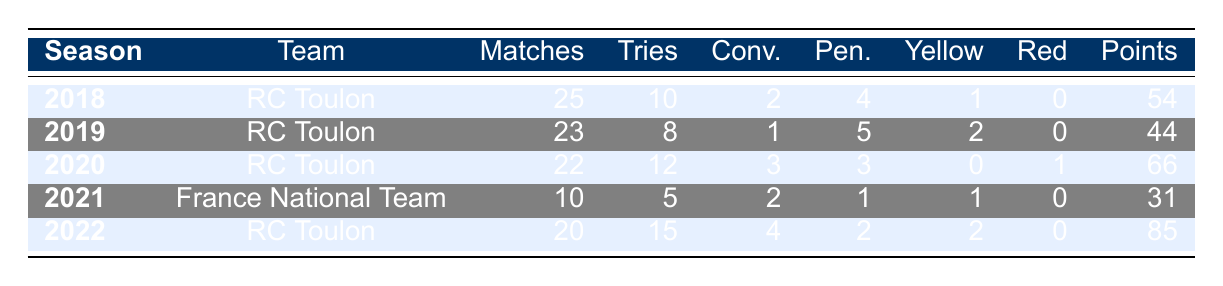What was Léo Laurent's highest total points scored in a season? In the table, the total points for each season are as follows: 54 (2018), 44 (2019), 66 (2020), 31 (2021), and 85 (2022). The highest value is 85, which corresponds to the 2022 season.
Answer: 85 How many matches did Léo Laurent play in total over all seasons listed? To find the total matches played, we need to sum the Matches Played column: 25 (2018) + 23 (2019) + 22 (2020) + 10 (2021) + 20 (2022) = 100.
Answer: 100 Did Léo Laurent receive any red cards during the 2019 season? In the 2019 season, the table indicates that he received 0 red cards. Therefore, the answer is no.
Answer: No In which season did Léo Laurent score the most tries? Looking at the Tries column, the values are 10 (2018), 8 (2019), 12 (2020), 5 (2021), and 15 (2022). The highest number of tries is 15 in the 2022 season.
Answer: 2022 What is the average number of yellow cards per season for Léo Laurent? The yellow cards per season are 1 (2018), 2 (2019), 0 (2020), 1 (2021), and 2 (2022). We sum these to get 6 yellow cards over 5 seasons: 6 / 5 = 1.2.
Answer: 1.2 Was Léo Laurent part of the France National Team in 2020? According to the table, Léo Laurent played for RC Toulon in 2020, not the France National Team. Therefore, the answer is no.
Answer: No How many penalties did Léo Laurent score in the season he played for the France National Team? In the 2021 season for the France National Team, he scored 1 penalty goal, as indicated in the table.
Answer: 1 Which season had the lowest total points scored by Léo Laurent? The total points are 54 (2018), 44 (2019), 66 (2020), 31 (2021), and 85 (2022). The lowest total points scored is 31, which belongs to the 2021 season.
Answer: 2021 What was the difference in total points scored between the 2020 and 2021 seasons? From the table, total points for 2020 is 66 and for 2021 is 31. The difference is 66 - 31 = 35.
Answer: 35 